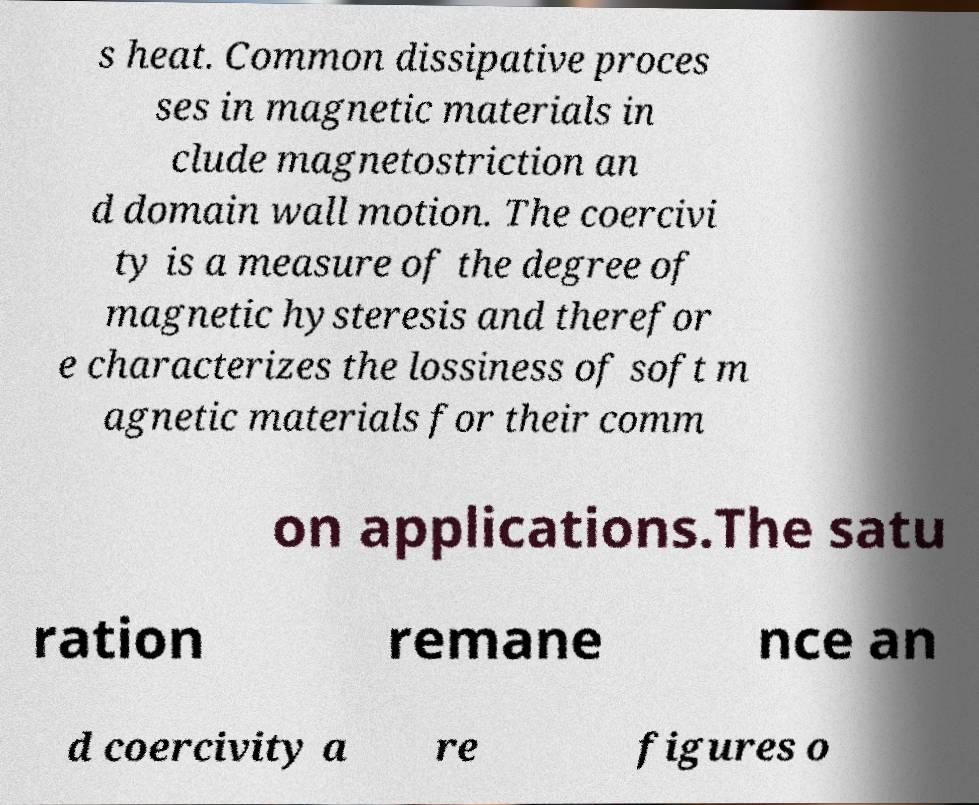Please read and relay the text visible in this image. What does it say? s heat. Common dissipative proces ses in magnetic materials in clude magnetostriction an d domain wall motion. The coercivi ty is a measure of the degree of magnetic hysteresis and therefor e characterizes the lossiness of soft m agnetic materials for their comm on applications.The satu ration remane nce an d coercivity a re figures o 